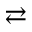Convert formula to latex. <formula><loc_0><loc_0><loc_500><loc_500>\right l e f t a r r o w s</formula> 